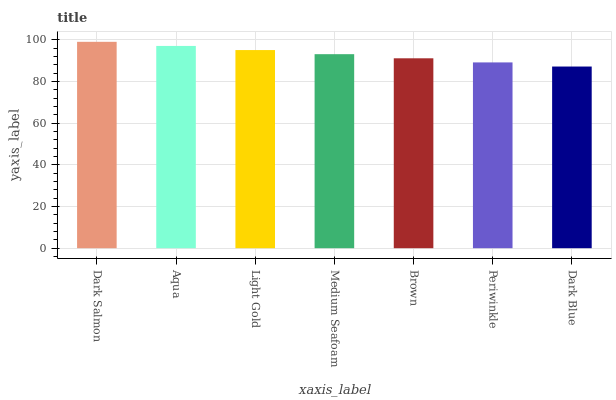Is Dark Blue the minimum?
Answer yes or no. Yes. Is Dark Salmon the maximum?
Answer yes or no. Yes. Is Aqua the minimum?
Answer yes or no. No. Is Aqua the maximum?
Answer yes or no. No. Is Dark Salmon greater than Aqua?
Answer yes or no. Yes. Is Aqua less than Dark Salmon?
Answer yes or no. Yes. Is Aqua greater than Dark Salmon?
Answer yes or no. No. Is Dark Salmon less than Aqua?
Answer yes or no. No. Is Medium Seafoam the high median?
Answer yes or no. Yes. Is Medium Seafoam the low median?
Answer yes or no. Yes. Is Periwinkle the high median?
Answer yes or no. No. Is Light Gold the low median?
Answer yes or no. No. 